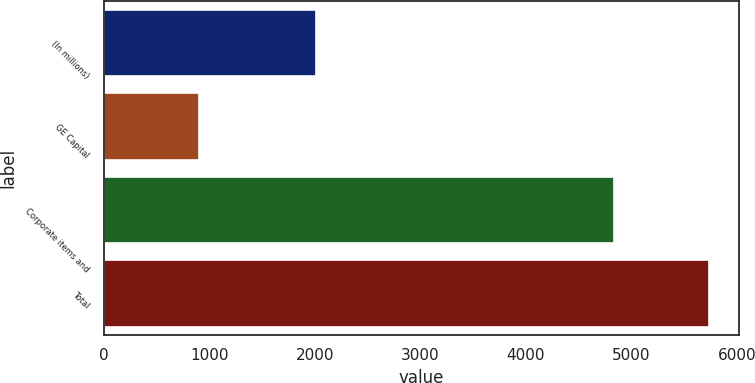Convert chart. <chart><loc_0><loc_0><loc_500><loc_500><bar_chart><fcel>(In millions)<fcel>GE Capital<fcel>Corporate items and<fcel>Total<nl><fcel>2011<fcel>899<fcel>4839<fcel>5738<nl></chart> 